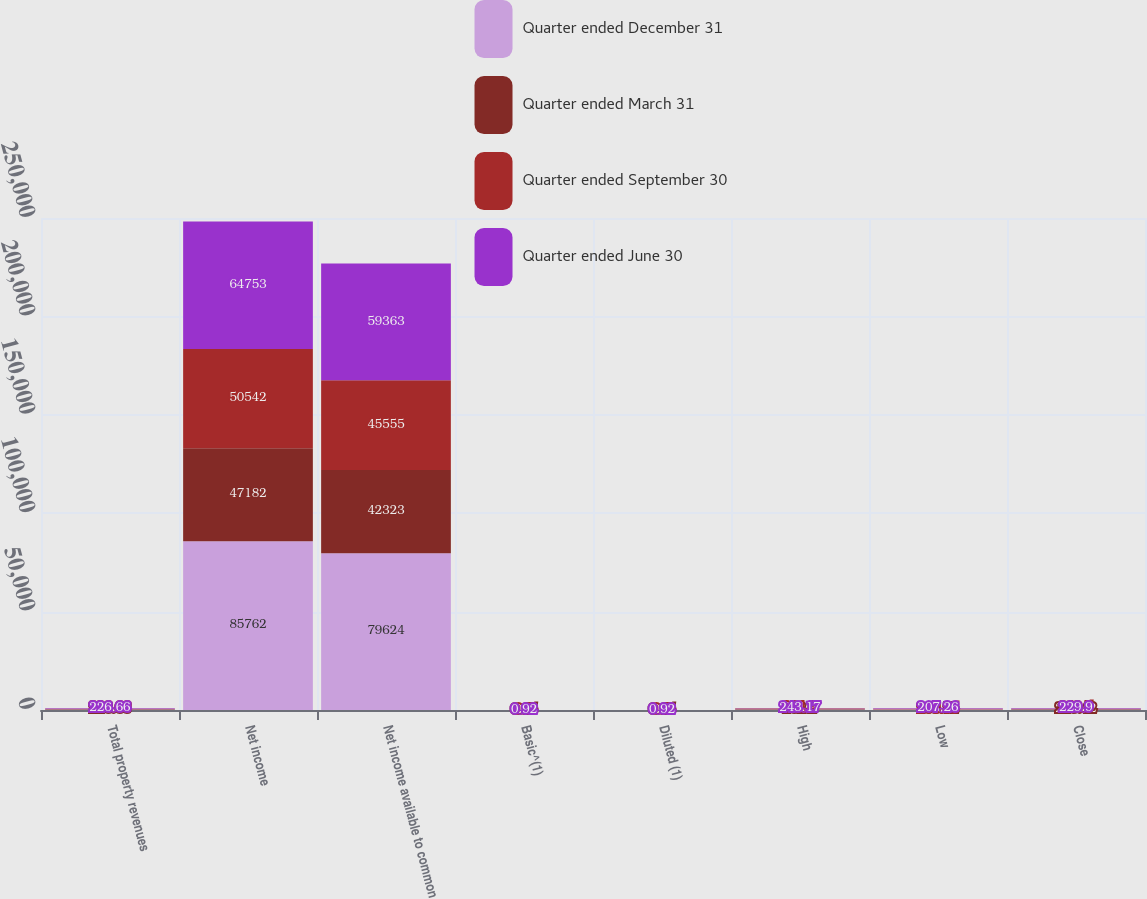Convert chart. <chart><loc_0><loc_0><loc_500><loc_500><stacked_bar_chart><ecel><fcel>Total property revenues<fcel>Net income<fcel>Net income available to common<fcel>Basic^(1)<fcel>Diluted (1)<fcel>High<fcel>Low<fcel>Close<nl><fcel>Quarter ended December 31<fcel>226.66<fcel>85762<fcel>79624<fcel>1.22<fcel>1.22<fcel>244.71<fcel>214.29<fcel>239.41<nl><fcel>Quarter ended March 31<fcel>226.66<fcel>47182<fcel>42323<fcel>0.65<fcel>0.65<fcel>232.2<fcel>205.72<fcel>223.42<nl><fcel>Quarter ended September 30<fcel>226.66<fcel>50542<fcel>45555<fcel>0.7<fcel>0.7<fcel>231.9<fcel>208.85<fcel>212.5<nl><fcel>Quarter ended June 30<fcel>226.66<fcel>64753<fcel>59363<fcel>0.92<fcel>0.92<fcel>243.17<fcel>207.26<fcel>229.9<nl></chart> 